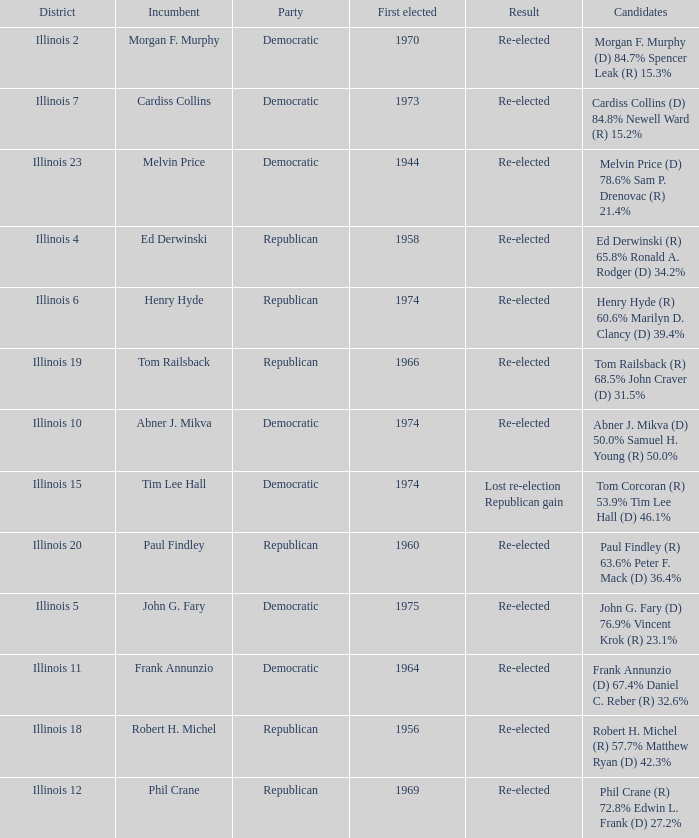Name the total number of incumbent for first elected of 1944 1.0. 